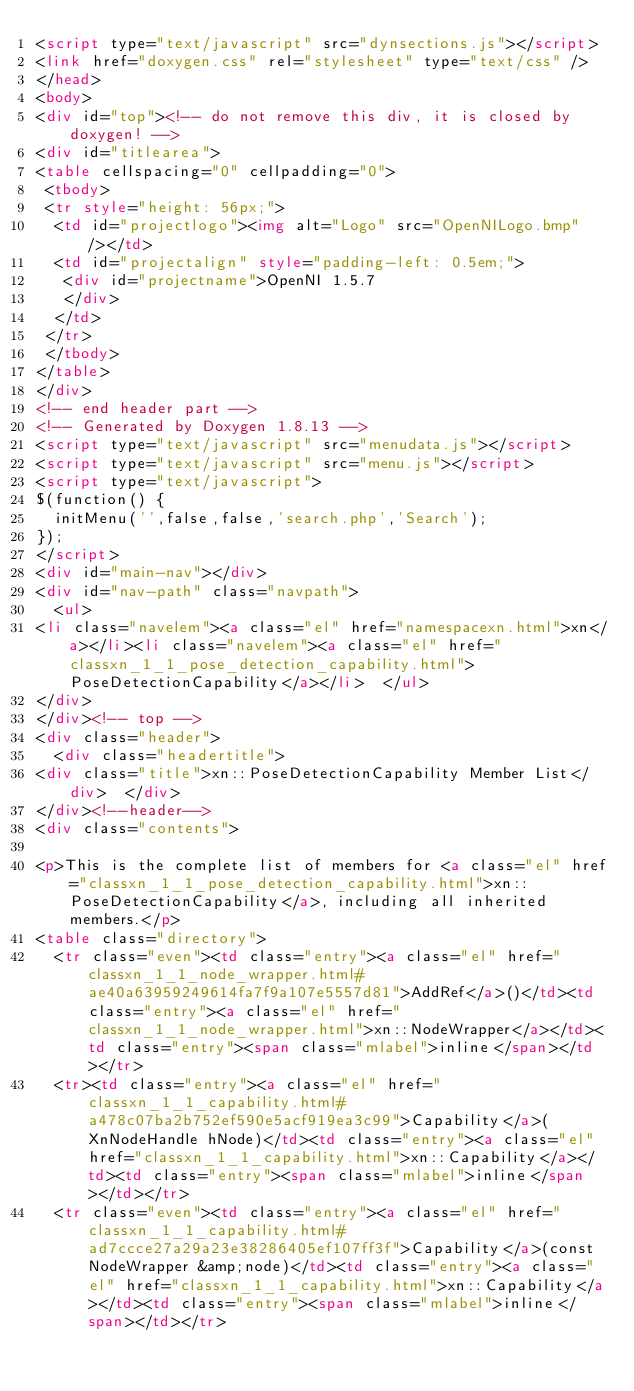<code> <loc_0><loc_0><loc_500><loc_500><_HTML_><script type="text/javascript" src="dynsections.js"></script>
<link href="doxygen.css" rel="stylesheet" type="text/css" />
</head>
<body>
<div id="top"><!-- do not remove this div, it is closed by doxygen! -->
<div id="titlearea">
<table cellspacing="0" cellpadding="0">
 <tbody>
 <tr style="height: 56px;">
  <td id="projectlogo"><img alt="Logo" src="OpenNILogo.bmp"/></td>
  <td id="projectalign" style="padding-left: 0.5em;">
   <div id="projectname">OpenNI 1.5.7
   </div>
  </td>
 </tr>
 </tbody>
</table>
</div>
<!-- end header part -->
<!-- Generated by Doxygen 1.8.13 -->
<script type="text/javascript" src="menudata.js"></script>
<script type="text/javascript" src="menu.js"></script>
<script type="text/javascript">
$(function() {
  initMenu('',false,false,'search.php','Search');
});
</script>
<div id="main-nav"></div>
<div id="nav-path" class="navpath">
  <ul>
<li class="navelem"><a class="el" href="namespacexn.html">xn</a></li><li class="navelem"><a class="el" href="classxn_1_1_pose_detection_capability.html">PoseDetectionCapability</a></li>  </ul>
</div>
</div><!-- top -->
<div class="header">
  <div class="headertitle">
<div class="title">xn::PoseDetectionCapability Member List</div>  </div>
</div><!--header-->
<div class="contents">

<p>This is the complete list of members for <a class="el" href="classxn_1_1_pose_detection_capability.html">xn::PoseDetectionCapability</a>, including all inherited members.</p>
<table class="directory">
  <tr class="even"><td class="entry"><a class="el" href="classxn_1_1_node_wrapper.html#ae40a63959249614fa7f9a107e5557d81">AddRef</a>()</td><td class="entry"><a class="el" href="classxn_1_1_node_wrapper.html">xn::NodeWrapper</a></td><td class="entry"><span class="mlabel">inline</span></td></tr>
  <tr><td class="entry"><a class="el" href="classxn_1_1_capability.html#a478c07ba2b752ef590e5acf919ea3c99">Capability</a>(XnNodeHandle hNode)</td><td class="entry"><a class="el" href="classxn_1_1_capability.html">xn::Capability</a></td><td class="entry"><span class="mlabel">inline</span></td></tr>
  <tr class="even"><td class="entry"><a class="el" href="classxn_1_1_capability.html#ad7ccce27a29a23e38286405ef107ff3f">Capability</a>(const NodeWrapper &amp;node)</td><td class="entry"><a class="el" href="classxn_1_1_capability.html">xn::Capability</a></td><td class="entry"><span class="mlabel">inline</span></td></tr></code> 